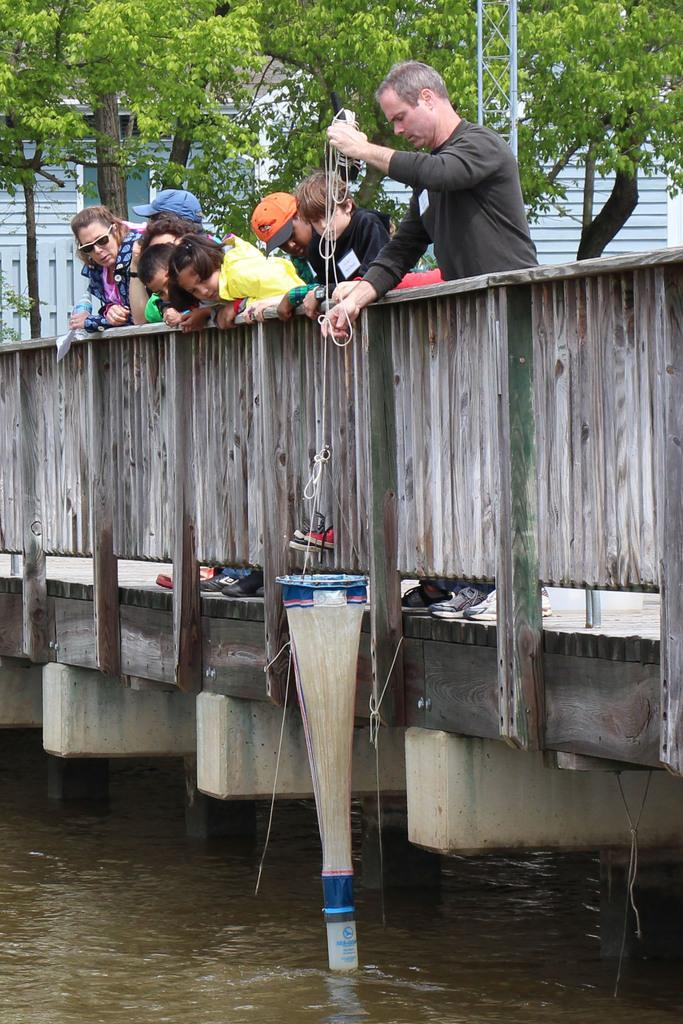What body of water is present in the image? There is a lake in the image. What structure is built over the lake? There is a bridge above the lake. What are the people on the bridge doing? The people standing on the bridge are observing the scene. What activity is the man engaged in? A man is catching fish with a net. What can be seen in the distance in the image? There are trees in the background of the image. What type of jam is being sold at the business in the image? There is no business or jam present in the image. What historical event is depicted in the image? There is no historical event depicted in the image; it shows a lake, a bridge, people, and a man fishing. 